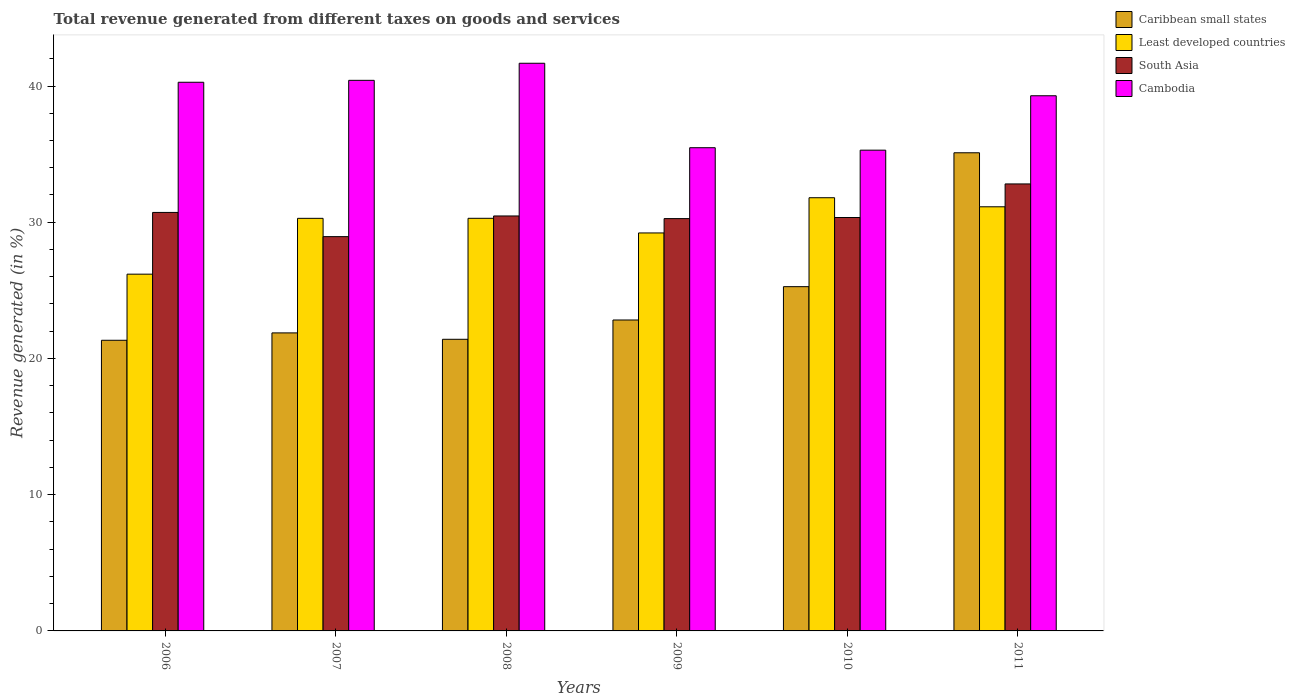What is the total revenue generated in Cambodia in 2008?
Your answer should be very brief. 41.67. Across all years, what is the maximum total revenue generated in South Asia?
Your answer should be compact. 32.81. Across all years, what is the minimum total revenue generated in Least developed countries?
Keep it short and to the point. 26.19. In which year was the total revenue generated in Caribbean small states minimum?
Provide a short and direct response. 2006. What is the total total revenue generated in Cambodia in the graph?
Your response must be concise. 232.41. What is the difference between the total revenue generated in South Asia in 2006 and that in 2009?
Offer a terse response. 0.45. What is the difference between the total revenue generated in South Asia in 2011 and the total revenue generated in Cambodia in 2010?
Offer a terse response. -2.48. What is the average total revenue generated in Least developed countries per year?
Make the answer very short. 29.82. In the year 2009, what is the difference between the total revenue generated in Caribbean small states and total revenue generated in South Asia?
Provide a succinct answer. -7.44. What is the ratio of the total revenue generated in Caribbean small states in 2009 to that in 2011?
Your response must be concise. 0.65. Is the total revenue generated in Least developed countries in 2007 less than that in 2009?
Give a very brief answer. No. Is the difference between the total revenue generated in Caribbean small states in 2008 and 2011 greater than the difference between the total revenue generated in South Asia in 2008 and 2011?
Your answer should be compact. No. What is the difference between the highest and the second highest total revenue generated in Least developed countries?
Ensure brevity in your answer.  0.67. What is the difference between the highest and the lowest total revenue generated in Cambodia?
Offer a terse response. 6.38. Is the sum of the total revenue generated in Cambodia in 2006 and 2008 greater than the maximum total revenue generated in Least developed countries across all years?
Your answer should be compact. Yes. Is it the case that in every year, the sum of the total revenue generated in Least developed countries and total revenue generated in Caribbean small states is greater than the sum of total revenue generated in South Asia and total revenue generated in Cambodia?
Ensure brevity in your answer.  No. What does the 3rd bar from the left in 2007 represents?
Provide a succinct answer. South Asia. Is it the case that in every year, the sum of the total revenue generated in Cambodia and total revenue generated in Caribbean small states is greater than the total revenue generated in South Asia?
Keep it short and to the point. Yes. How many bars are there?
Keep it short and to the point. 24. What is the difference between two consecutive major ticks on the Y-axis?
Your answer should be compact. 10. Are the values on the major ticks of Y-axis written in scientific E-notation?
Make the answer very short. No. Does the graph contain grids?
Your answer should be compact. No. How many legend labels are there?
Your answer should be compact. 4. How are the legend labels stacked?
Keep it short and to the point. Vertical. What is the title of the graph?
Make the answer very short. Total revenue generated from different taxes on goods and services. What is the label or title of the X-axis?
Your answer should be very brief. Years. What is the label or title of the Y-axis?
Your response must be concise. Revenue generated (in %). What is the Revenue generated (in %) of Caribbean small states in 2006?
Offer a very short reply. 21.34. What is the Revenue generated (in %) in Least developed countries in 2006?
Give a very brief answer. 26.19. What is the Revenue generated (in %) of South Asia in 2006?
Offer a very short reply. 30.72. What is the Revenue generated (in %) of Cambodia in 2006?
Ensure brevity in your answer.  40.28. What is the Revenue generated (in %) in Caribbean small states in 2007?
Offer a very short reply. 21.88. What is the Revenue generated (in %) of Least developed countries in 2007?
Offer a very short reply. 30.29. What is the Revenue generated (in %) of South Asia in 2007?
Your answer should be compact. 28.94. What is the Revenue generated (in %) in Cambodia in 2007?
Ensure brevity in your answer.  40.42. What is the Revenue generated (in %) in Caribbean small states in 2008?
Your response must be concise. 21.41. What is the Revenue generated (in %) in Least developed countries in 2008?
Keep it short and to the point. 30.29. What is the Revenue generated (in %) in South Asia in 2008?
Give a very brief answer. 30.46. What is the Revenue generated (in %) of Cambodia in 2008?
Make the answer very short. 41.67. What is the Revenue generated (in %) in Caribbean small states in 2009?
Provide a short and direct response. 22.82. What is the Revenue generated (in %) in Least developed countries in 2009?
Provide a succinct answer. 29.21. What is the Revenue generated (in %) in South Asia in 2009?
Ensure brevity in your answer.  30.27. What is the Revenue generated (in %) of Cambodia in 2009?
Give a very brief answer. 35.47. What is the Revenue generated (in %) of Caribbean small states in 2010?
Provide a succinct answer. 25.27. What is the Revenue generated (in %) of Least developed countries in 2010?
Your response must be concise. 31.8. What is the Revenue generated (in %) in South Asia in 2010?
Provide a short and direct response. 30.35. What is the Revenue generated (in %) in Cambodia in 2010?
Make the answer very short. 35.29. What is the Revenue generated (in %) in Caribbean small states in 2011?
Provide a succinct answer. 35.1. What is the Revenue generated (in %) of Least developed countries in 2011?
Offer a very short reply. 31.13. What is the Revenue generated (in %) in South Asia in 2011?
Offer a very short reply. 32.81. What is the Revenue generated (in %) in Cambodia in 2011?
Give a very brief answer. 39.28. Across all years, what is the maximum Revenue generated (in %) in Caribbean small states?
Your response must be concise. 35.1. Across all years, what is the maximum Revenue generated (in %) of Least developed countries?
Offer a terse response. 31.8. Across all years, what is the maximum Revenue generated (in %) in South Asia?
Provide a succinct answer. 32.81. Across all years, what is the maximum Revenue generated (in %) of Cambodia?
Keep it short and to the point. 41.67. Across all years, what is the minimum Revenue generated (in %) in Caribbean small states?
Keep it short and to the point. 21.34. Across all years, what is the minimum Revenue generated (in %) in Least developed countries?
Keep it short and to the point. 26.19. Across all years, what is the minimum Revenue generated (in %) of South Asia?
Offer a very short reply. 28.94. Across all years, what is the minimum Revenue generated (in %) in Cambodia?
Ensure brevity in your answer.  35.29. What is the total Revenue generated (in %) in Caribbean small states in the graph?
Offer a very short reply. 147.81. What is the total Revenue generated (in %) in Least developed countries in the graph?
Provide a short and direct response. 178.91. What is the total Revenue generated (in %) of South Asia in the graph?
Give a very brief answer. 183.55. What is the total Revenue generated (in %) of Cambodia in the graph?
Offer a very short reply. 232.41. What is the difference between the Revenue generated (in %) in Caribbean small states in 2006 and that in 2007?
Offer a terse response. -0.54. What is the difference between the Revenue generated (in %) in Least developed countries in 2006 and that in 2007?
Your answer should be very brief. -4.1. What is the difference between the Revenue generated (in %) of South Asia in 2006 and that in 2007?
Your response must be concise. 1.78. What is the difference between the Revenue generated (in %) in Cambodia in 2006 and that in 2007?
Offer a very short reply. -0.14. What is the difference between the Revenue generated (in %) of Caribbean small states in 2006 and that in 2008?
Offer a terse response. -0.07. What is the difference between the Revenue generated (in %) in Least developed countries in 2006 and that in 2008?
Provide a short and direct response. -4.1. What is the difference between the Revenue generated (in %) of South Asia in 2006 and that in 2008?
Your answer should be very brief. 0.26. What is the difference between the Revenue generated (in %) of Cambodia in 2006 and that in 2008?
Offer a very short reply. -1.39. What is the difference between the Revenue generated (in %) in Caribbean small states in 2006 and that in 2009?
Your answer should be compact. -1.49. What is the difference between the Revenue generated (in %) in Least developed countries in 2006 and that in 2009?
Offer a terse response. -3.03. What is the difference between the Revenue generated (in %) of South Asia in 2006 and that in 2009?
Keep it short and to the point. 0.45. What is the difference between the Revenue generated (in %) in Cambodia in 2006 and that in 2009?
Offer a very short reply. 4.8. What is the difference between the Revenue generated (in %) of Caribbean small states in 2006 and that in 2010?
Keep it short and to the point. -3.94. What is the difference between the Revenue generated (in %) of Least developed countries in 2006 and that in 2010?
Ensure brevity in your answer.  -5.61. What is the difference between the Revenue generated (in %) in South Asia in 2006 and that in 2010?
Offer a terse response. 0.37. What is the difference between the Revenue generated (in %) of Cambodia in 2006 and that in 2010?
Keep it short and to the point. 4.99. What is the difference between the Revenue generated (in %) in Caribbean small states in 2006 and that in 2011?
Your response must be concise. -13.76. What is the difference between the Revenue generated (in %) in Least developed countries in 2006 and that in 2011?
Offer a very short reply. -4.95. What is the difference between the Revenue generated (in %) in South Asia in 2006 and that in 2011?
Make the answer very short. -2.09. What is the difference between the Revenue generated (in %) of Caribbean small states in 2007 and that in 2008?
Ensure brevity in your answer.  0.47. What is the difference between the Revenue generated (in %) of Least developed countries in 2007 and that in 2008?
Your response must be concise. -0. What is the difference between the Revenue generated (in %) of South Asia in 2007 and that in 2008?
Give a very brief answer. -1.52. What is the difference between the Revenue generated (in %) of Cambodia in 2007 and that in 2008?
Give a very brief answer. -1.25. What is the difference between the Revenue generated (in %) of Caribbean small states in 2007 and that in 2009?
Make the answer very short. -0.95. What is the difference between the Revenue generated (in %) in Least developed countries in 2007 and that in 2009?
Offer a terse response. 1.07. What is the difference between the Revenue generated (in %) of South Asia in 2007 and that in 2009?
Your answer should be compact. -1.32. What is the difference between the Revenue generated (in %) in Cambodia in 2007 and that in 2009?
Keep it short and to the point. 4.95. What is the difference between the Revenue generated (in %) in Caribbean small states in 2007 and that in 2010?
Keep it short and to the point. -3.39. What is the difference between the Revenue generated (in %) of Least developed countries in 2007 and that in 2010?
Your response must be concise. -1.51. What is the difference between the Revenue generated (in %) of South Asia in 2007 and that in 2010?
Your answer should be very brief. -1.4. What is the difference between the Revenue generated (in %) in Cambodia in 2007 and that in 2010?
Ensure brevity in your answer.  5.13. What is the difference between the Revenue generated (in %) of Caribbean small states in 2007 and that in 2011?
Your answer should be very brief. -13.22. What is the difference between the Revenue generated (in %) in Least developed countries in 2007 and that in 2011?
Offer a terse response. -0.85. What is the difference between the Revenue generated (in %) of South Asia in 2007 and that in 2011?
Offer a terse response. -3.87. What is the difference between the Revenue generated (in %) of Cambodia in 2007 and that in 2011?
Your answer should be compact. 1.13. What is the difference between the Revenue generated (in %) in Caribbean small states in 2008 and that in 2009?
Make the answer very short. -1.42. What is the difference between the Revenue generated (in %) of Least developed countries in 2008 and that in 2009?
Provide a succinct answer. 1.07. What is the difference between the Revenue generated (in %) in South Asia in 2008 and that in 2009?
Provide a succinct answer. 0.19. What is the difference between the Revenue generated (in %) in Cambodia in 2008 and that in 2009?
Your response must be concise. 6.2. What is the difference between the Revenue generated (in %) in Caribbean small states in 2008 and that in 2010?
Your answer should be very brief. -3.86. What is the difference between the Revenue generated (in %) of Least developed countries in 2008 and that in 2010?
Offer a very short reply. -1.51. What is the difference between the Revenue generated (in %) in South Asia in 2008 and that in 2010?
Make the answer very short. 0.11. What is the difference between the Revenue generated (in %) of Cambodia in 2008 and that in 2010?
Offer a very short reply. 6.38. What is the difference between the Revenue generated (in %) in Caribbean small states in 2008 and that in 2011?
Keep it short and to the point. -13.69. What is the difference between the Revenue generated (in %) of Least developed countries in 2008 and that in 2011?
Provide a succinct answer. -0.85. What is the difference between the Revenue generated (in %) in South Asia in 2008 and that in 2011?
Your answer should be very brief. -2.35. What is the difference between the Revenue generated (in %) in Cambodia in 2008 and that in 2011?
Provide a succinct answer. 2.39. What is the difference between the Revenue generated (in %) in Caribbean small states in 2009 and that in 2010?
Your answer should be very brief. -2.45. What is the difference between the Revenue generated (in %) in Least developed countries in 2009 and that in 2010?
Your answer should be very brief. -2.58. What is the difference between the Revenue generated (in %) in South Asia in 2009 and that in 2010?
Your response must be concise. -0.08. What is the difference between the Revenue generated (in %) of Cambodia in 2009 and that in 2010?
Make the answer very short. 0.18. What is the difference between the Revenue generated (in %) of Caribbean small states in 2009 and that in 2011?
Make the answer very short. -12.27. What is the difference between the Revenue generated (in %) of Least developed countries in 2009 and that in 2011?
Offer a terse response. -1.92. What is the difference between the Revenue generated (in %) of South Asia in 2009 and that in 2011?
Provide a short and direct response. -2.55. What is the difference between the Revenue generated (in %) of Cambodia in 2009 and that in 2011?
Give a very brief answer. -3.81. What is the difference between the Revenue generated (in %) of Caribbean small states in 2010 and that in 2011?
Keep it short and to the point. -9.83. What is the difference between the Revenue generated (in %) in Least developed countries in 2010 and that in 2011?
Your answer should be very brief. 0.67. What is the difference between the Revenue generated (in %) in South Asia in 2010 and that in 2011?
Provide a short and direct response. -2.46. What is the difference between the Revenue generated (in %) in Cambodia in 2010 and that in 2011?
Your response must be concise. -3.99. What is the difference between the Revenue generated (in %) in Caribbean small states in 2006 and the Revenue generated (in %) in Least developed countries in 2007?
Give a very brief answer. -8.95. What is the difference between the Revenue generated (in %) of Caribbean small states in 2006 and the Revenue generated (in %) of South Asia in 2007?
Keep it short and to the point. -7.61. What is the difference between the Revenue generated (in %) of Caribbean small states in 2006 and the Revenue generated (in %) of Cambodia in 2007?
Provide a short and direct response. -19.08. What is the difference between the Revenue generated (in %) in Least developed countries in 2006 and the Revenue generated (in %) in South Asia in 2007?
Your answer should be very brief. -2.75. What is the difference between the Revenue generated (in %) in Least developed countries in 2006 and the Revenue generated (in %) in Cambodia in 2007?
Make the answer very short. -14.23. What is the difference between the Revenue generated (in %) of South Asia in 2006 and the Revenue generated (in %) of Cambodia in 2007?
Keep it short and to the point. -9.7. What is the difference between the Revenue generated (in %) in Caribbean small states in 2006 and the Revenue generated (in %) in Least developed countries in 2008?
Provide a succinct answer. -8.95. What is the difference between the Revenue generated (in %) in Caribbean small states in 2006 and the Revenue generated (in %) in South Asia in 2008?
Provide a succinct answer. -9.13. What is the difference between the Revenue generated (in %) in Caribbean small states in 2006 and the Revenue generated (in %) in Cambodia in 2008?
Make the answer very short. -20.34. What is the difference between the Revenue generated (in %) in Least developed countries in 2006 and the Revenue generated (in %) in South Asia in 2008?
Make the answer very short. -4.27. What is the difference between the Revenue generated (in %) of Least developed countries in 2006 and the Revenue generated (in %) of Cambodia in 2008?
Keep it short and to the point. -15.48. What is the difference between the Revenue generated (in %) in South Asia in 2006 and the Revenue generated (in %) in Cambodia in 2008?
Your answer should be very brief. -10.95. What is the difference between the Revenue generated (in %) in Caribbean small states in 2006 and the Revenue generated (in %) in Least developed countries in 2009?
Your response must be concise. -7.88. What is the difference between the Revenue generated (in %) in Caribbean small states in 2006 and the Revenue generated (in %) in South Asia in 2009?
Your response must be concise. -8.93. What is the difference between the Revenue generated (in %) in Caribbean small states in 2006 and the Revenue generated (in %) in Cambodia in 2009?
Offer a terse response. -14.14. What is the difference between the Revenue generated (in %) in Least developed countries in 2006 and the Revenue generated (in %) in South Asia in 2009?
Ensure brevity in your answer.  -4.08. What is the difference between the Revenue generated (in %) in Least developed countries in 2006 and the Revenue generated (in %) in Cambodia in 2009?
Keep it short and to the point. -9.28. What is the difference between the Revenue generated (in %) of South Asia in 2006 and the Revenue generated (in %) of Cambodia in 2009?
Ensure brevity in your answer.  -4.75. What is the difference between the Revenue generated (in %) in Caribbean small states in 2006 and the Revenue generated (in %) in Least developed countries in 2010?
Offer a terse response. -10.46. What is the difference between the Revenue generated (in %) of Caribbean small states in 2006 and the Revenue generated (in %) of South Asia in 2010?
Give a very brief answer. -9.01. What is the difference between the Revenue generated (in %) in Caribbean small states in 2006 and the Revenue generated (in %) in Cambodia in 2010?
Make the answer very short. -13.96. What is the difference between the Revenue generated (in %) of Least developed countries in 2006 and the Revenue generated (in %) of South Asia in 2010?
Your answer should be compact. -4.16. What is the difference between the Revenue generated (in %) of Least developed countries in 2006 and the Revenue generated (in %) of Cambodia in 2010?
Your answer should be very brief. -9.1. What is the difference between the Revenue generated (in %) in South Asia in 2006 and the Revenue generated (in %) in Cambodia in 2010?
Give a very brief answer. -4.57. What is the difference between the Revenue generated (in %) in Caribbean small states in 2006 and the Revenue generated (in %) in Least developed countries in 2011?
Make the answer very short. -9.8. What is the difference between the Revenue generated (in %) of Caribbean small states in 2006 and the Revenue generated (in %) of South Asia in 2011?
Provide a short and direct response. -11.48. What is the difference between the Revenue generated (in %) of Caribbean small states in 2006 and the Revenue generated (in %) of Cambodia in 2011?
Your answer should be very brief. -17.95. What is the difference between the Revenue generated (in %) of Least developed countries in 2006 and the Revenue generated (in %) of South Asia in 2011?
Offer a very short reply. -6.62. What is the difference between the Revenue generated (in %) in Least developed countries in 2006 and the Revenue generated (in %) in Cambodia in 2011?
Give a very brief answer. -13.1. What is the difference between the Revenue generated (in %) in South Asia in 2006 and the Revenue generated (in %) in Cambodia in 2011?
Your answer should be compact. -8.57. What is the difference between the Revenue generated (in %) of Caribbean small states in 2007 and the Revenue generated (in %) of Least developed countries in 2008?
Offer a very short reply. -8.41. What is the difference between the Revenue generated (in %) of Caribbean small states in 2007 and the Revenue generated (in %) of South Asia in 2008?
Your answer should be very brief. -8.58. What is the difference between the Revenue generated (in %) in Caribbean small states in 2007 and the Revenue generated (in %) in Cambodia in 2008?
Offer a very short reply. -19.79. What is the difference between the Revenue generated (in %) of Least developed countries in 2007 and the Revenue generated (in %) of South Asia in 2008?
Offer a very short reply. -0.17. What is the difference between the Revenue generated (in %) in Least developed countries in 2007 and the Revenue generated (in %) in Cambodia in 2008?
Your answer should be compact. -11.38. What is the difference between the Revenue generated (in %) of South Asia in 2007 and the Revenue generated (in %) of Cambodia in 2008?
Ensure brevity in your answer.  -12.73. What is the difference between the Revenue generated (in %) in Caribbean small states in 2007 and the Revenue generated (in %) in Least developed countries in 2009?
Offer a terse response. -7.34. What is the difference between the Revenue generated (in %) of Caribbean small states in 2007 and the Revenue generated (in %) of South Asia in 2009?
Your response must be concise. -8.39. What is the difference between the Revenue generated (in %) in Caribbean small states in 2007 and the Revenue generated (in %) in Cambodia in 2009?
Make the answer very short. -13.59. What is the difference between the Revenue generated (in %) of Least developed countries in 2007 and the Revenue generated (in %) of South Asia in 2009?
Your response must be concise. 0.02. What is the difference between the Revenue generated (in %) in Least developed countries in 2007 and the Revenue generated (in %) in Cambodia in 2009?
Your answer should be very brief. -5.18. What is the difference between the Revenue generated (in %) of South Asia in 2007 and the Revenue generated (in %) of Cambodia in 2009?
Provide a succinct answer. -6.53. What is the difference between the Revenue generated (in %) of Caribbean small states in 2007 and the Revenue generated (in %) of Least developed countries in 2010?
Offer a terse response. -9.92. What is the difference between the Revenue generated (in %) of Caribbean small states in 2007 and the Revenue generated (in %) of South Asia in 2010?
Give a very brief answer. -8.47. What is the difference between the Revenue generated (in %) in Caribbean small states in 2007 and the Revenue generated (in %) in Cambodia in 2010?
Your answer should be very brief. -13.41. What is the difference between the Revenue generated (in %) of Least developed countries in 2007 and the Revenue generated (in %) of South Asia in 2010?
Give a very brief answer. -0.06. What is the difference between the Revenue generated (in %) in Least developed countries in 2007 and the Revenue generated (in %) in Cambodia in 2010?
Make the answer very short. -5. What is the difference between the Revenue generated (in %) in South Asia in 2007 and the Revenue generated (in %) in Cambodia in 2010?
Your answer should be compact. -6.35. What is the difference between the Revenue generated (in %) of Caribbean small states in 2007 and the Revenue generated (in %) of Least developed countries in 2011?
Ensure brevity in your answer.  -9.26. What is the difference between the Revenue generated (in %) of Caribbean small states in 2007 and the Revenue generated (in %) of South Asia in 2011?
Offer a terse response. -10.94. What is the difference between the Revenue generated (in %) in Caribbean small states in 2007 and the Revenue generated (in %) in Cambodia in 2011?
Your answer should be very brief. -17.41. What is the difference between the Revenue generated (in %) in Least developed countries in 2007 and the Revenue generated (in %) in South Asia in 2011?
Give a very brief answer. -2.53. What is the difference between the Revenue generated (in %) in Least developed countries in 2007 and the Revenue generated (in %) in Cambodia in 2011?
Your response must be concise. -9. What is the difference between the Revenue generated (in %) in South Asia in 2007 and the Revenue generated (in %) in Cambodia in 2011?
Ensure brevity in your answer.  -10.34. What is the difference between the Revenue generated (in %) in Caribbean small states in 2008 and the Revenue generated (in %) in Least developed countries in 2009?
Ensure brevity in your answer.  -7.81. What is the difference between the Revenue generated (in %) of Caribbean small states in 2008 and the Revenue generated (in %) of South Asia in 2009?
Your answer should be compact. -8.86. What is the difference between the Revenue generated (in %) of Caribbean small states in 2008 and the Revenue generated (in %) of Cambodia in 2009?
Provide a succinct answer. -14.06. What is the difference between the Revenue generated (in %) in Least developed countries in 2008 and the Revenue generated (in %) in South Asia in 2009?
Provide a succinct answer. 0.02. What is the difference between the Revenue generated (in %) in Least developed countries in 2008 and the Revenue generated (in %) in Cambodia in 2009?
Ensure brevity in your answer.  -5.18. What is the difference between the Revenue generated (in %) in South Asia in 2008 and the Revenue generated (in %) in Cambodia in 2009?
Offer a terse response. -5.01. What is the difference between the Revenue generated (in %) in Caribbean small states in 2008 and the Revenue generated (in %) in Least developed countries in 2010?
Provide a short and direct response. -10.39. What is the difference between the Revenue generated (in %) in Caribbean small states in 2008 and the Revenue generated (in %) in South Asia in 2010?
Your answer should be very brief. -8.94. What is the difference between the Revenue generated (in %) of Caribbean small states in 2008 and the Revenue generated (in %) of Cambodia in 2010?
Ensure brevity in your answer.  -13.88. What is the difference between the Revenue generated (in %) in Least developed countries in 2008 and the Revenue generated (in %) in South Asia in 2010?
Ensure brevity in your answer.  -0.06. What is the difference between the Revenue generated (in %) of Least developed countries in 2008 and the Revenue generated (in %) of Cambodia in 2010?
Give a very brief answer. -5. What is the difference between the Revenue generated (in %) in South Asia in 2008 and the Revenue generated (in %) in Cambodia in 2010?
Keep it short and to the point. -4.83. What is the difference between the Revenue generated (in %) of Caribbean small states in 2008 and the Revenue generated (in %) of Least developed countries in 2011?
Your answer should be compact. -9.73. What is the difference between the Revenue generated (in %) in Caribbean small states in 2008 and the Revenue generated (in %) in South Asia in 2011?
Offer a very short reply. -11.41. What is the difference between the Revenue generated (in %) of Caribbean small states in 2008 and the Revenue generated (in %) of Cambodia in 2011?
Provide a succinct answer. -17.88. What is the difference between the Revenue generated (in %) of Least developed countries in 2008 and the Revenue generated (in %) of South Asia in 2011?
Your answer should be compact. -2.52. What is the difference between the Revenue generated (in %) in Least developed countries in 2008 and the Revenue generated (in %) in Cambodia in 2011?
Keep it short and to the point. -9. What is the difference between the Revenue generated (in %) of South Asia in 2008 and the Revenue generated (in %) of Cambodia in 2011?
Your answer should be very brief. -8.82. What is the difference between the Revenue generated (in %) in Caribbean small states in 2009 and the Revenue generated (in %) in Least developed countries in 2010?
Provide a succinct answer. -8.97. What is the difference between the Revenue generated (in %) in Caribbean small states in 2009 and the Revenue generated (in %) in South Asia in 2010?
Offer a very short reply. -7.52. What is the difference between the Revenue generated (in %) in Caribbean small states in 2009 and the Revenue generated (in %) in Cambodia in 2010?
Your answer should be compact. -12.47. What is the difference between the Revenue generated (in %) of Least developed countries in 2009 and the Revenue generated (in %) of South Asia in 2010?
Keep it short and to the point. -1.13. What is the difference between the Revenue generated (in %) in Least developed countries in 2009 and the Revenue generated (in %) in Cambodia in 2010?
Offer a terse response. -6.08. What is the difference between the Revenue generated (in %) in South Asia in 2009 and the Revenue generated (in %) in Cambodia in 2010?
Give a very brief answer. -5.02. What is the difference between the Revenue generated (in %) in Caribbean small states in 2009 and the Revenue generated (in %) in Least developed countries in 2011?
Offer a very short reply. -8.31. What is the difference between the Revenue generated (in %) of Caribbean small states in 2009 and the Revenue generated (in %) of South Asia in 2011?
Keep it short and to the point. -9.99. What is the difference between the Revenue generated (in %) in Caribbean small states in 2009 and the Revenue generated (in %) in Cambodia in 2011?
Ensure brevity in your answer.  -16.46. What is the difference between the Revenue generated (in %) of Least developed countries in 2009 and the Revenue generated (in %) of South Asia in 2011?
Your response must be concise. -3.6. What is the difference between the Revenue generated (in %) in Least developed countries in 2009 and the Revenue generated (in %) in Cambodia in 2011?
Provide a succinct answer. -10.07. What is the difference between the Revenue generated (in %) of South Asia in 2009 and the Revenue generated (in %) of Cambodia in 2011?
Your answer should be compact. -9.02. What is the difference between the Revenue generated (in %) in Caribbean small states in 2010 and the Revenue generated (in %) in Least developed countries in 2011?
Your response must be concise. -5.86. What is the difference between the Revenue generated (in %) in Caribbean small states in 2010 and the Revenue generated (in %) in South Asia in 2011?
Your answer should be very brief. -7.54. What is the difference between the Revenue generated (in %) in Caribbean small states in 2010 and the Revenue generated (in %) in Cambodia in 2011?
Your response must be concise. -14.01. What is the difference between the Revenue generated (in %) in Least developed countries in 2010 and the Revenue generated (in %) in South Asia in 2011?
Provide a short and direct response. -1.01. What is the difference between the Revenue generated (in %) in Least developed countries in 2010 and the Revenue generated (in %) in Cambodia in 2011?
Keep it short and to the point. -7.49. What is the difference between the Revenue generated (in %) in South Asia in 2010 and the Revenue generated (in %) in Cambodia in 2011?
Your answer should be compact. -8.94. What is the average Revenue generated (in %) of Caribbean small states per year?
Offer a terse response. 24.64. What is the average Revenue generated (in %) of Least developed countries per year?
Your response must be concise. 29.82. What is the average Revenue generated (in %) in South Asia per year?
Provide a succinct answer. 30.59. What is the average Revenue generated (in %) in Cambodia per year?
Provide a short and direct response. 38.73. In the year 2006, what is the difference between the Revenue generated (in %) of Caribbean small states and Revenue generated (in %) of Least developed countries?
Offer a very short reply. -4.85. In the year 2006, what is the difference between the Revenue generated (in %) of Caribbean small states and Revenue generated (in %) of South Asia?
Provide a short and direct response. -9.38. In the year 2006, what is the difference between the Revenue generated (in %) in Caribbean small states and Revenue generated (in %) in Cambodia?
Your answer should be compact. -18.94. In the year 2006, what is the difference between the Revenue generated (in %) in Least developed countries and Revenue generated (in %) in South Asia?
Your answer should be very brief. -4.53. In the year 2006, what is the difference between the Revenue generated (in %) in Least developed countries and Revenue generated (in %) in Cambodia?
Your response must be concise. -14.09. In the year 2006, what is the difference between the Revenue generated (in %) of South Asia and Revenue generated (in %) of Cambodia?
Make the answer very short. -9.56. In the year 2007, what is the difference between the Revenue generated (in %) of Caribbean small states and Revenue generated (in %) of Least developed countries?
Offer a very short reply. -8.41. In the year 2007, what is the difference between the Revenue generated (in %) of Caribbean small states and Revenue generated (in %) of South Asia?
Offer a terse response. -7.07. In the year 2007, what is the difference between the Revenue generated (in %) of Caribbean small states and Revenue generated (in %) of Cambodia?
Offer a terse response. -18.54. In the year 2007, what is the difference between the Revenue generated (in %) in Least developed countries and Revenue generated (in %) in South Asia?
Offer a terse response. 1.34. In the year 2007, what is the difference between the Revenue generated (in %) of Least developed countries and Revenue generated (in %) of Cambodia?
Your answer should be compact. -10.13. In the year 2007, what is the difference between the Revenue generated (in %) in South Asia and Revenue generated (in %) in Cambodia?
Keep it short and to the point. -11.47. In the year 2008, what is the difference between the Revenue generated (in %) of Caribbean small states and Revenue generated (in %) of Least developed countries?
Make the answer very short. -8.88. In the year 2008, what is the difference between the Revenue generated (in %) of Caribbean small states and Revenue generated (in %) of South Asia?
Make the answer very short. -9.05. In the year 2008, what is the difference between the Revenue generated (in %) in Caribbean small states and Revenue generated (in %) in Cambodia?
Make the answer very short. -20.26. In the year 2008, what is the difference between the Revenue generated (in %) of Least developed countries and Revenue generated (in %) of South Asia?
Provide a succinct answer. -0.17. In the year 2008, what is the difference between the Revenue generated (in %) of Least developed countries and Revenue generated (in %) of Cambodia?
Offer a terse response. -11.38. In the year 2008, what is the difference between the Revenue generated (in %) in South Asia and Revenue generated (in %) in Cambodia?
Your response must be concise. -11.21. In the year 2009, what is the difference between the Revenue generated (in %) in Caribbean small states and Revenue generated (in %) in Least developed countries?
Ensure brevity in your answer.  -6.39. In the year 2009, what is the difference between the Revenue generated (in %) of Caribbean small states and Revenue generated (in %) of South Asia?
Your answer should be compact. -7.44. In the year 2009, what is the difference between the Revenue generated (in %) of Caribbean small states and Revenue generated (in %) of Cambodia?
Ensure brevity in your answer.  -12.65. In the year 2009, what is the difference between the Revenue generated (in %) in Least developed countries and Revenue generated (in %) in South Asia?
Your response must be concise. -1.05. In the year 2009, what is the difference between the Revenue generated (in %) of Least developed countries and Revenue generated (in %) of Cambodia?
Keep it short and to the point. -6.26. In the year 2009, what is the difference between the Revenue generated (in %) of South Asia and Revenue generated (in %) of Cambodia?
Give a very brief answer. -5.2. In the year 2010, what is the difference between the Revenue generated (in %) in Caribbean small states and Revenue generated (in %) in Least developed countries?
Offer a terse response. -6.53. In the year 2010, what is the difference between the Revenue generated (in %) of Caribbean small states and Revenue generated (in %) of South Asia?
Offer a very short reply. -5.08. In the year 2010, what is the difference between the Revenue generated (in %) in Caribbean small states and Revenue generated (in %) in Cambodia?
Provide a short and direct response. -10.02. In the year 2010, what is the difference between the Revenue generated (in %) in Least developed countries and Revenue generated (in %) in South Asia?
Provide a succinct answer. 1.45. In the year 2010, what is the difference between the Revenue generated (in %) of Least developed countries and Revenue generated (in %) of Cambodia?
Give a very brief answer. -3.49. In the year 2010, what is the difference between the Revenue generated (in %) of South Asia and Revenue generated (in %) of Cambodia?
Offer a terse response. -4.94. In the year 2011, what is the difference between the Revenue generated (in %) in Caribbean small states and Revenue generated (in %) in Least developed countries?
Give a very brief answer. 3.96. In the year 2011, what is the difference between the Revenue generated (in %) in Caribbean small states and Revenue generated (in %) in South Asia?
Offer a very short reply. 2.29. In the year 2011, what is the difference between the Revenue generated (in %) in Caribbean small states and Revenue generated (in %) in Cambodia?
Your response must be concise. -4.19. In the year 2011, what is the difference between the Revenue generated (in %) of Least developed countries and Revenue generated (in %) of South Asia?
Your answer should be compact. -1.68. In the year 2011, what is the difference between the Revenue generated (in %) of Least developed countries and Revenue generated (in %) of Cambodia?
Keep it short and to the point. -8.15. In the year 2011, what is the difference between the Revenue generated (in %) in South Asia and Revenue generated (in %) in Cambodia?
Your answer should be compact. -6.47. What is the ratio of the Revenue generated (in %) in Caribbean small states in 2006 to that in 2007?
Offer a very short reply. 0.98. What is the ratio of the Revenue generated (in %) of Least developed countries in 2006 to that in 2007?
Keep it short and to the point. 0.86. What is the ratio of the Revenue generated (in %) of South Asia in 2006 to that in 2007?
Keep it short and to the point. 1.06. What is the ratio of the Revenue generated (in %) in Caribbean small states in 2006 to that in 2008?
Your answer should be very brief. 1. What is the ratio of the Revenue generated (in %) in Least developed countries in 2006 to that in 2008?
Give a very brief answer. 0.86. What is the ratio of the Revenue generated (in %) of South Asia in 2006 to that in 2008?
Provide a succinct answer. 1.01. What is the ratio of the Revenue generated (in %) in Cambodia in 2006 to that in 2008?
Offer a terse response. 0.97. What is the ratio of the Revenue generated (in %) of Caribbean small states in 2006 to that in 2009?
Give a very brief answer. 0.93. What is the ratio of the Revenue generated (in %) of Least developed countries in 2006 to that in 2009?
Provide a succinct answer. 0.9. What is the ratio of the Revenue generated (in %) in South Asia in 2006 to that in 2009?
Give a very brief answer. 1.01. What is the ratio of the Revenue generated (in %) of Cambodia in 2006 to that in 2009?
Your response must be concise. 1.14. What is the ratio of the Revenue generated (in %) of Caribbean small states in 2006 to that in 2010?
Make the answer very short. 0.84. What is the ratio of the Revenue generated (in %) in Least developed countries in 2006 to that in 2010?
Give a very brief answer. 0.82. What is the ratio of the Revenue generated (in %) of South Asia in 2006 to that in 2010?
Keep it short and to the point. 1.01. What is the ratio of the Revenue generated (in %) in Cambodia in 2006 to that in 2010?
Provide a short and direct response. 1.14. What is the ratio of the Revenue generated (in %) in Caribbean small states in 2006 to that in 2011?
Your answer should be very brief. 0.61. What is the ratio of the Revenue generated (in %) of Least developed countries in 2006 to that in 2011?
Make the answer very short. 0.84. What is the ratio of the Revenue generated (in %) of South Asia in 2006 to that in 2011?
Provide a succinct answer. 0.94. What is the ratio of the Revenue generated (in %) of Cambodia in 2006 to that in 2011?
Your answer should be very brief. 1.03. What is the ratio of the Revenue generated (in %) in Caribbean small states in 2007 to that in 2008?
Give a very brief answer. 1.02. What is the ratio of the Revenue generated (in %) in Least developed countries in 2007 to that in 2008?
Make the answer very short. 1. What is the ratio of the Revenue generated (in %) of South Asia in 2007 to that in 2008?
Give a very brief answer. 0.95. What is the ratio of the Revenue generated (in %) of Cambodia in 2007 to that in 2008?
Provide a succinct answer. 0.97. What is the ratio of the Revenue generated (in %) in Caribbean small states in 2007 to that in 2009?
Your answer should be compact. 0.96. What is the ratio of the Revenue generated (in %) in Least developed countries in 2007 to that in 2009?
Your answer should be very brief. 1.04. What is the ratio of the Revenue generated (in %) in South Asia in 2007 to that in 2009?
Keep it short and to the point. 0.96. What is the ratio of the Revenue generated (in %) in Cambodia in 2007 to that in 2009?
Ensure brevity in your answer.  1.14. What is the ratio of the Revenue generated (in %) of Caribbean small states in 2007 to that in 2010?
Offer a terse response. 0.87. What is the ratio of the Revenue generated (in %) of Least developed countries in 2007 to that in 2010?
Offer a terse response. 0.95. What is the ratio of the Revenue generated (in %) of South Asia in 2007 to that in 2010?
Ensure brevity in your answer.  0.95. What is the ratio of the Revenue generated (in %) in Cambodia in 2007 to that in 2010?
Give a very brief answer. 1.15. What is the ratio of the Revenue generated (in %) of Caribbean small states in 2007 to that in 2011?
Your response must be concise. 0.62. What is the ratio of the Revenue generated (in %) in Least developed countries in 2007 to that in 2011?
Your response must be concise. 0.97. What is the ratio of the Revenue generated (in %) in South Asia in 2007 to that in 2011?
Your response must be concise. 0.88. What is the ratio of the Revenue generated (in %) of Cambodia in 2007 to that in 2011?
Make the answer very short. 1.03. What is the ratio of the Revenue generated (in %) of Caribbean small states in 2008 to that in 2009?
Offer a very short reply. 0.94. What is the ratio of the Revenue generated (in %) of Least developed countries in 2008 to that in 2009?
Make the answer very short. 1.04. What is the ratio of the Revenue generated (in %) of South Asia in 2008 to that in 2009?
Provide a succinct answer. 1.01. What is the ratio of the Revenue generated (in %) in Cambodia in 2008 to that in 2009?
Your answer should be very brief. 1.17. What is the ratio of the Revenue generated (in %) in Caribbean small states in 2008 to that in 2010?
Your answer should be very brief. 0.85. What is the ratio of the Revenue generated (in %) of Least developed countries in 2008 to that in 2010?
Keep it short and to the point. 0.95. What is the ratio of the Revenue generated (in %) of Cambodia in 2008 to that in 2010?
Keep it short and to the point. 1.18. What is the ratio of the Revenue generated (in %) in Caribbean small states in 2008 to that in 2011?
Offer a very short reply. 0.61. What is the ratio of the Revenue generated (in %) in Least developed countries in 2008 to that in 2011?
Your answer should be compact. 0.97. What is the ratio of the Revenue generated (in %) of South Asia in 2008 to that in 2011?
Offer a terse response. 0.93. What is the ratio of the Revenue generated (in %) of Cambodia in 2008 to that in 2011?
Make the answer very short. 1.06. What is the ratio of the Revenue generated (in %) of Caribbean small states in 2009 to that in 2010?
Your answer should be very brief. 0.9. What is the ratio of the Revenue generated (in %) in Least developed countries in 2009 to that in 2010?
Ensure brevity in your answer.  0.92. What is the ratio of the Revenue generated (in %) of Caribbean small states in 2009 to that in 2011?
Provide a short and direct response. 0.65. What is the ratio of the Revenue generated (in %) of Least developed countries in 2009 to that in 2011?
Give a very brief answer. 0.94. What is the ratio of the Revenue generated (in %) of South Asia in 2009 to that in 2011?
Your answer should be compact. 0.92. What is the ratio of the Revenue generated (in %) in Cambodia in 2009 to that in 2011?
Provide a short and direct response. 0.9. What is the ratio of the Revenue generated (in %) of Caribbean small states in 2010 to that in 2011?
Your answer should be compact. 0.72. What is the ratio of the Revenue generated (in %) of Least developed countries in 2010 to that in 2011?
Keep it short and to the point. 1.02. What is the ratio of the Revenue generated (in %) of South Asia in 2010 to that in 2011?
Give a very brief answer. 0.92. What is the ratio of the Revenue generated (in %) of Cambodia in 2010 to that in 2011?
Provide a short and direct response. 0.9. What is the difference between the highest and the second highest Revenue generated (in %) of Caribbean small states?
Ensure brevity in your answer.  9.83. What is the difference between the highest and the second highest Revenue generated (in %) of Least developed countries?
Offer a terse response. 0.67. What is the difference between the highest and the second highest Revenue generated (in %) in South Asia?
Provide a short and direct response. 2.09. What is the difference between the highest and the second highest Revenue generated (in %) of Cambodia?
Provide a succinct answer. 1.25. What is the difference between the highest and the lowest Revenue generated (in %) in Caribbean small states?
Make the answer very short. 13.76. What is the difference between the highest and the lowest Revenue generated (in %) in Least developed countries?
Provide a short and direct response. 5.61. What is the difference between the highest and the lowest Revenue generated (in %) in South Asia?
Provide a succinct answer. 3.87. What is the difference between the highest and the lowest Revenue generated (in %) in Cambodia?
Provide a succinct answer. 6.38. 